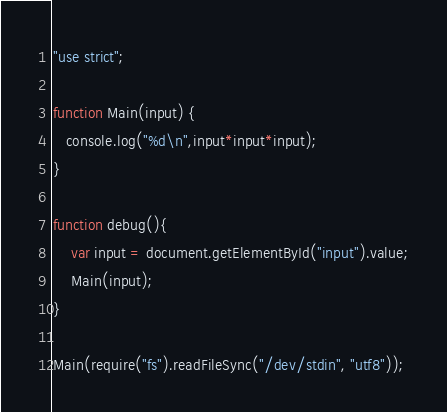<code> <loc_0><loc_0><loc_500><loc_500><_JavaScript_>"use strict";

function Main(input) {
   console.log("%d\n",input*input*input);
}

function debug(){
	var input = document.getElementById("input").value;
	Main(input);
}

Main(require("fs").readFileSync("/dev/stdin", "utf8"));</code> 